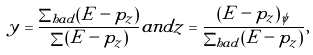<formula> <loc_0><loc_0><loc_500><loc_500>y = \frac { \sum _ { h a d } ( E - p _ { z } ) } { \sum ( E - p _ { z } ) } a n d z = \frac { ( E - p _ { z } ) _ { \psi } } { \sum _ { h a d } ( E - p _ { z } ) } ,</formula> 